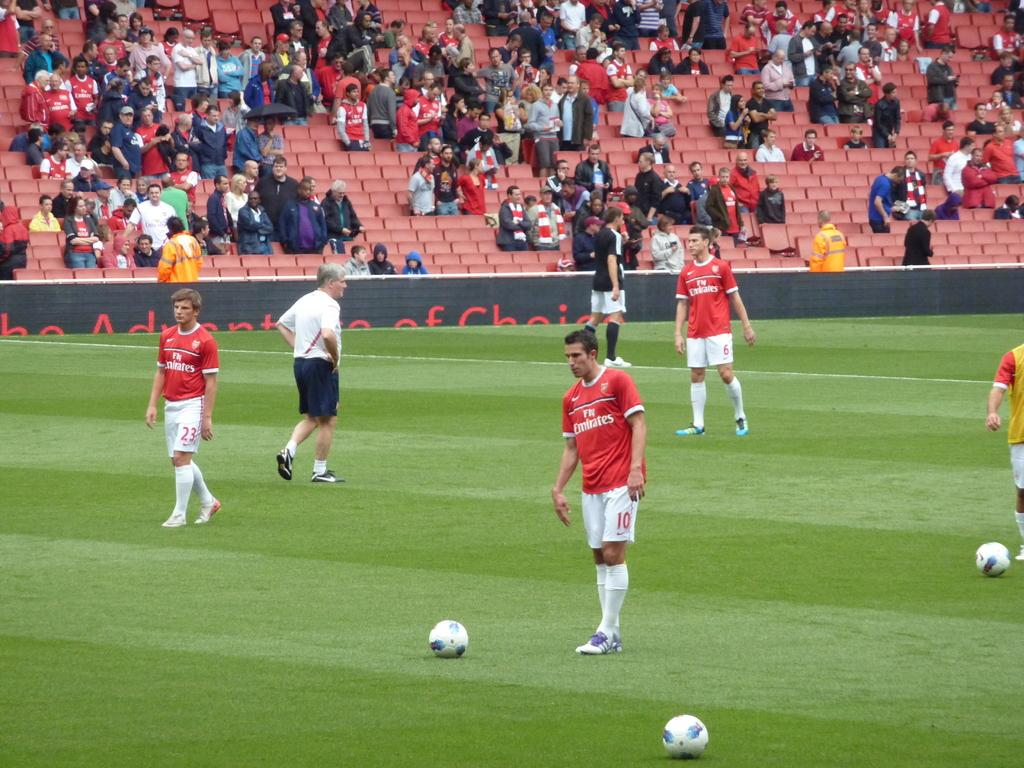Provide a one-sentence caption for the provided image. A soccer stadium filled with spectators watching a match for the Emirates. 